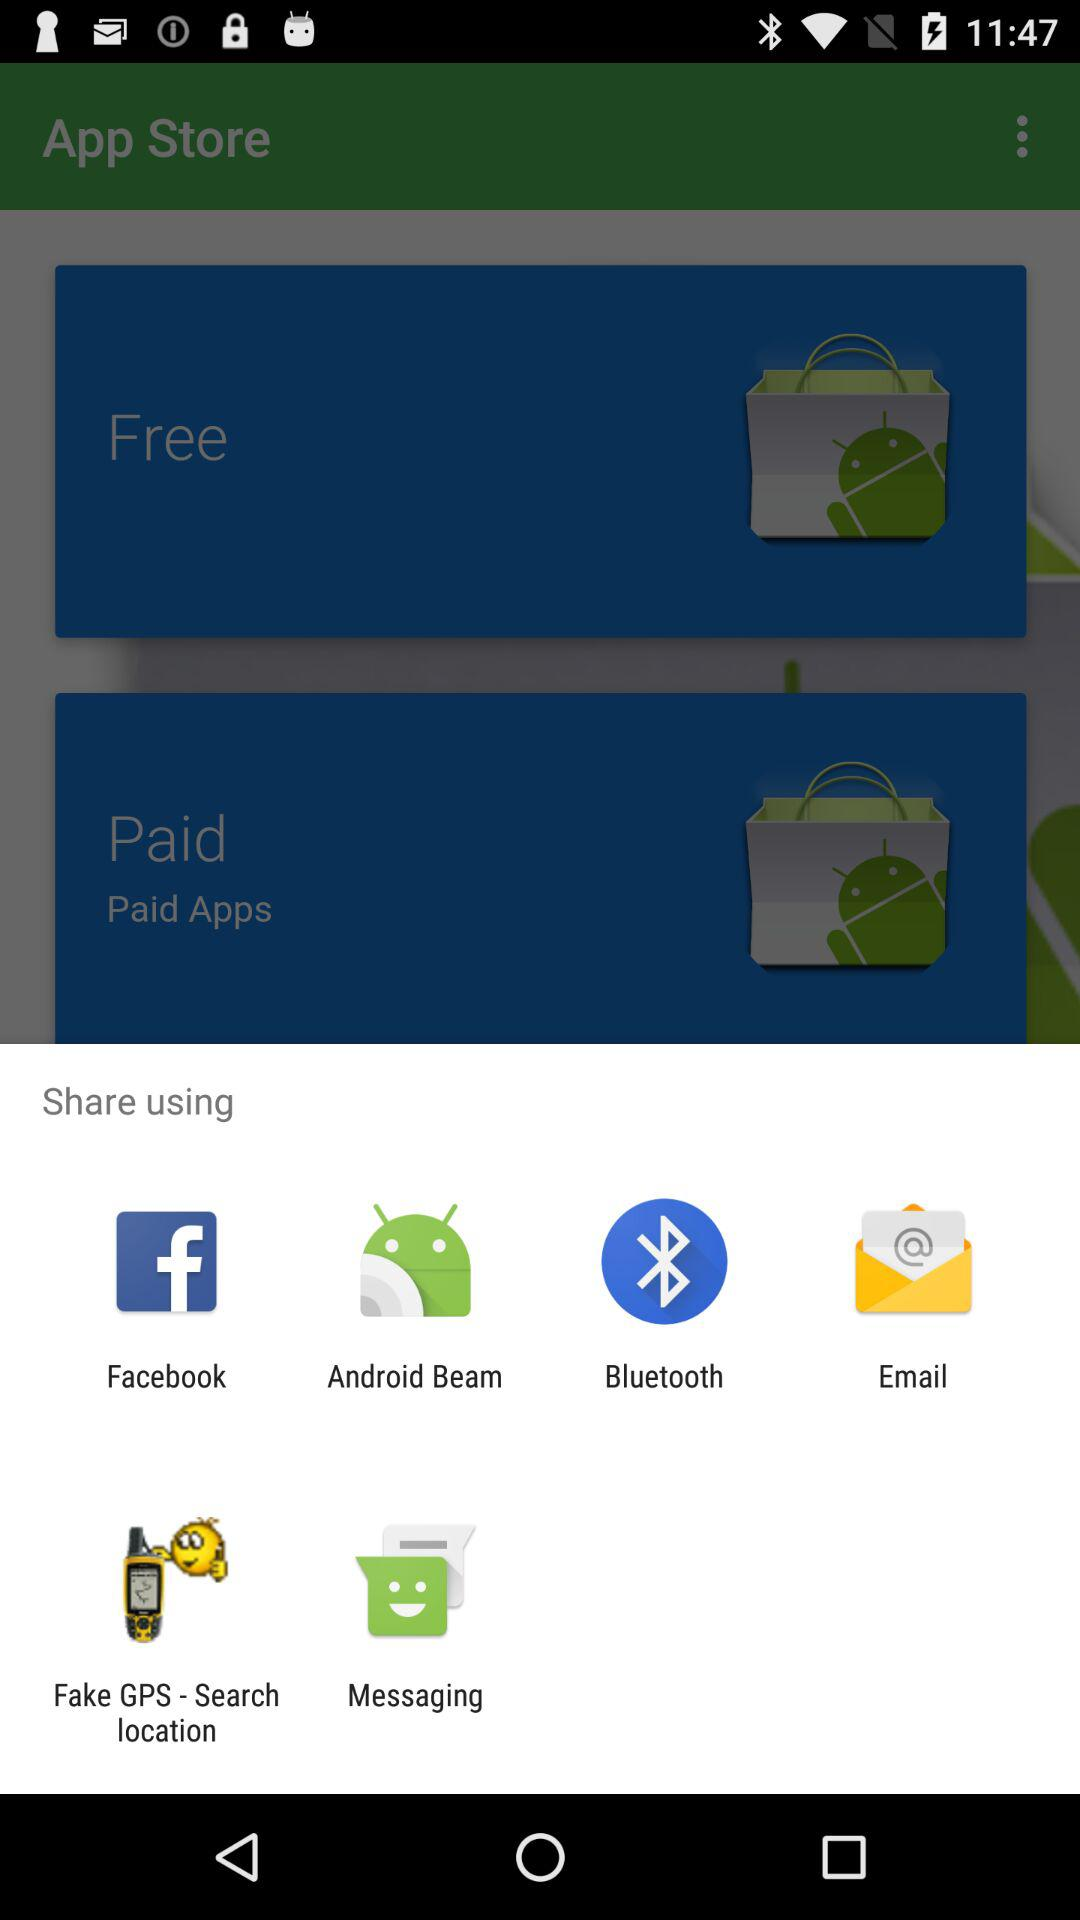How many free applications are in the store?
When the provided information is insufficient, respond with <no answer>. <no answer> 